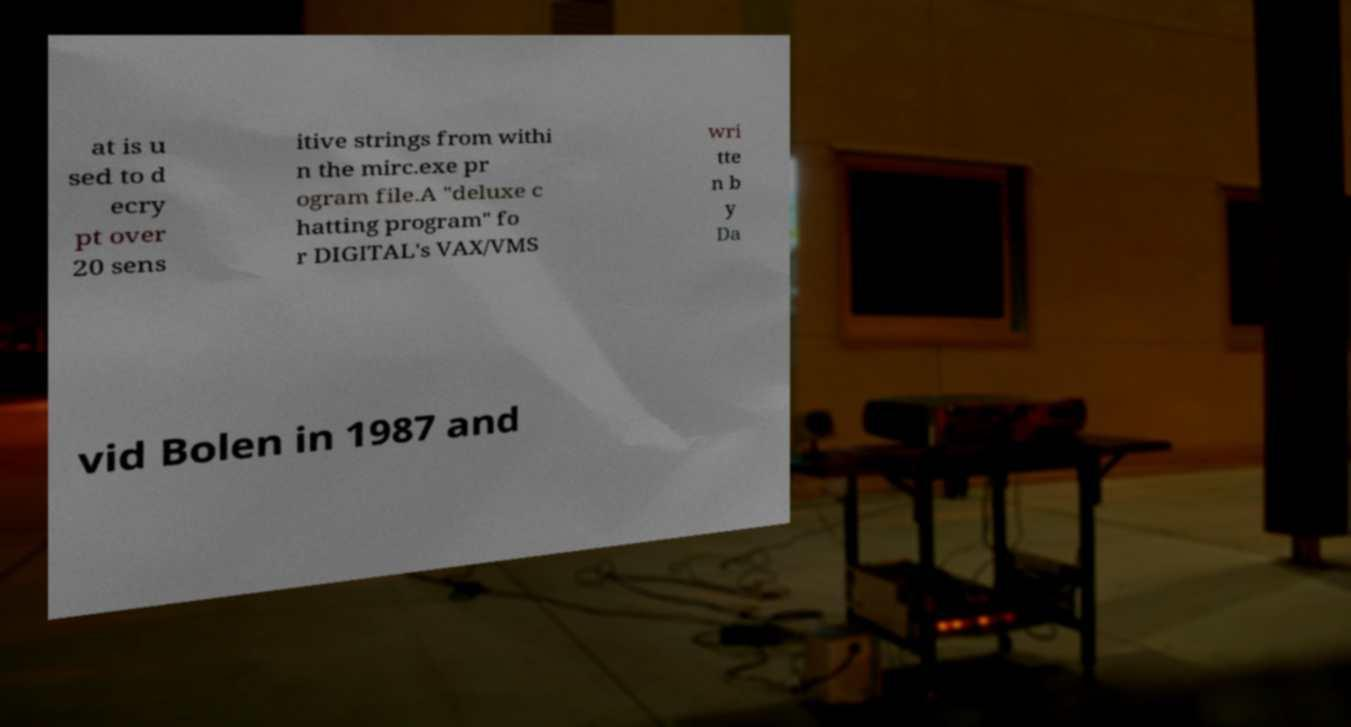Can you read and provide the text displayed in the image?This photo seems to have some interesting text. Can you extract and type it out for me? at is u sed to d ecry pt over 20 sens itive strings from withi n the mirc.exe pr ogram file.A "deluxe c hatting program" fo r DIGITAL's VAX/VMS wri tte n b y Da vid Bolen in 1987 and 